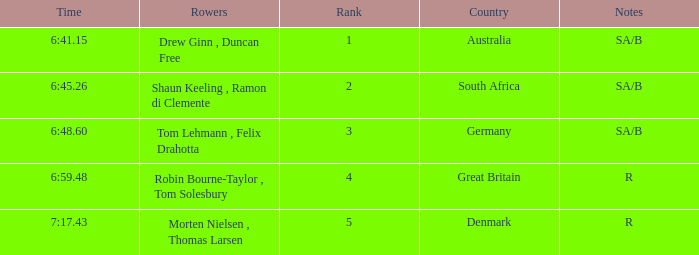What was the time for the rowers representing great britain? 6:59.48. Can you give me this table as a dict? {'header': ['Time', 'Rowers', 'Rank', 'Country', 'Notes'], 'rows': [['6:41.15', 'Drew Ginn , Duncan Free', '1', 'Australia', 'SA/B'], ['6:45.26', 'Shaun Keeling , Ramon di Clemente', '2', 'South Africa', 'SA/B'], ['6:48.60', 'Tom Lehmann , Felix Drahotta', '3', 'Germany', 'SA/B'], ['6:59.48', 'Robin Bourne-Taylor , Tom Solesbury', '4', 'Great Britain', 'R'], ['7:17.43', 'Morten Nielsen , Thomas Larsen', '5', 'Denmark', 'R']]} 